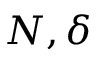<formula> <loc_0><loc_0><loc_500><loc_500>N , \delta</formula> 